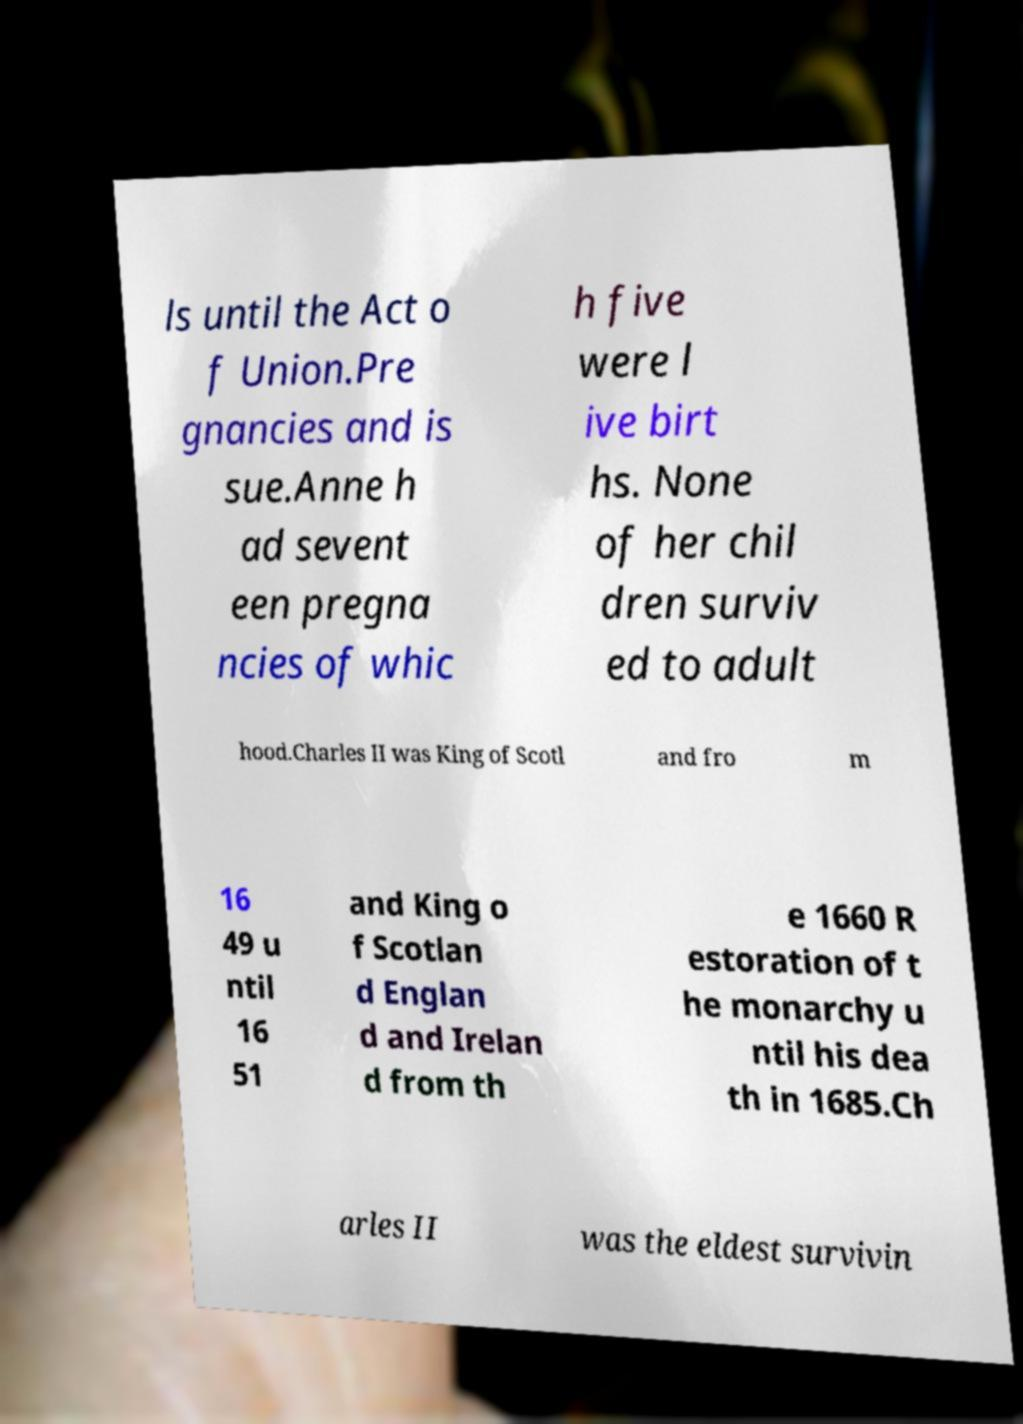Could you extract and type out the text from this image? ls until the Act o f Union.Pre gnancies and is sue.Anne h ad sevent een pregna ncies of whic h five were l ive birt hs. None of her chil dren surviv ed to adult hood.Charles II was King of Scotl and fro m 16 49 u ntil 16 51 and King o f Scotlan d Englan d and Irelan d from th e 1660 R estoration of t he monarchy u ntil his dea th in 1685.Ch arles II was the eldest survivin 